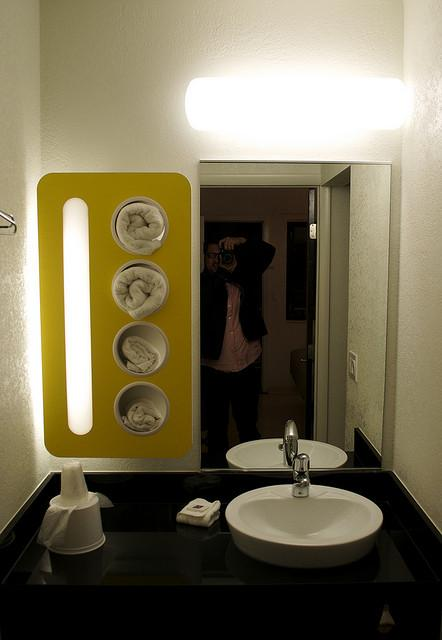What is near the sink? soap 